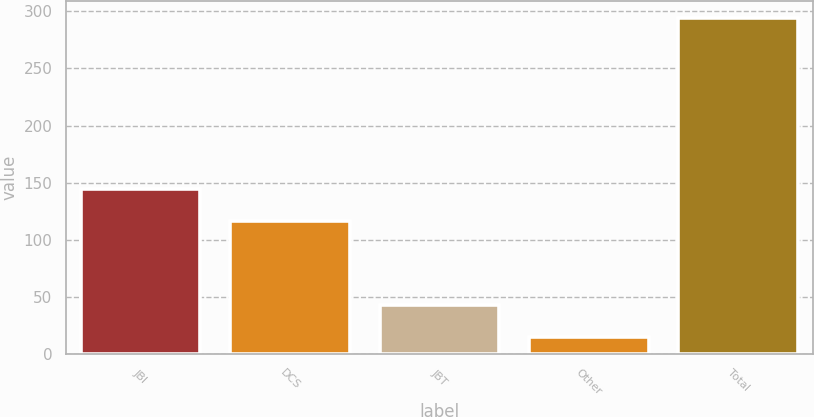<chart> <loc_0><loc_0><loc_500><loc_500><bar_chart><fcel>JBI<fcel>DCS<fcel>JBT<fcel>Other<fcel>Total<nl><fcel>144.9<fcel>117<fcel>42.9<fcel>15<fcel>294<nl></chart> 